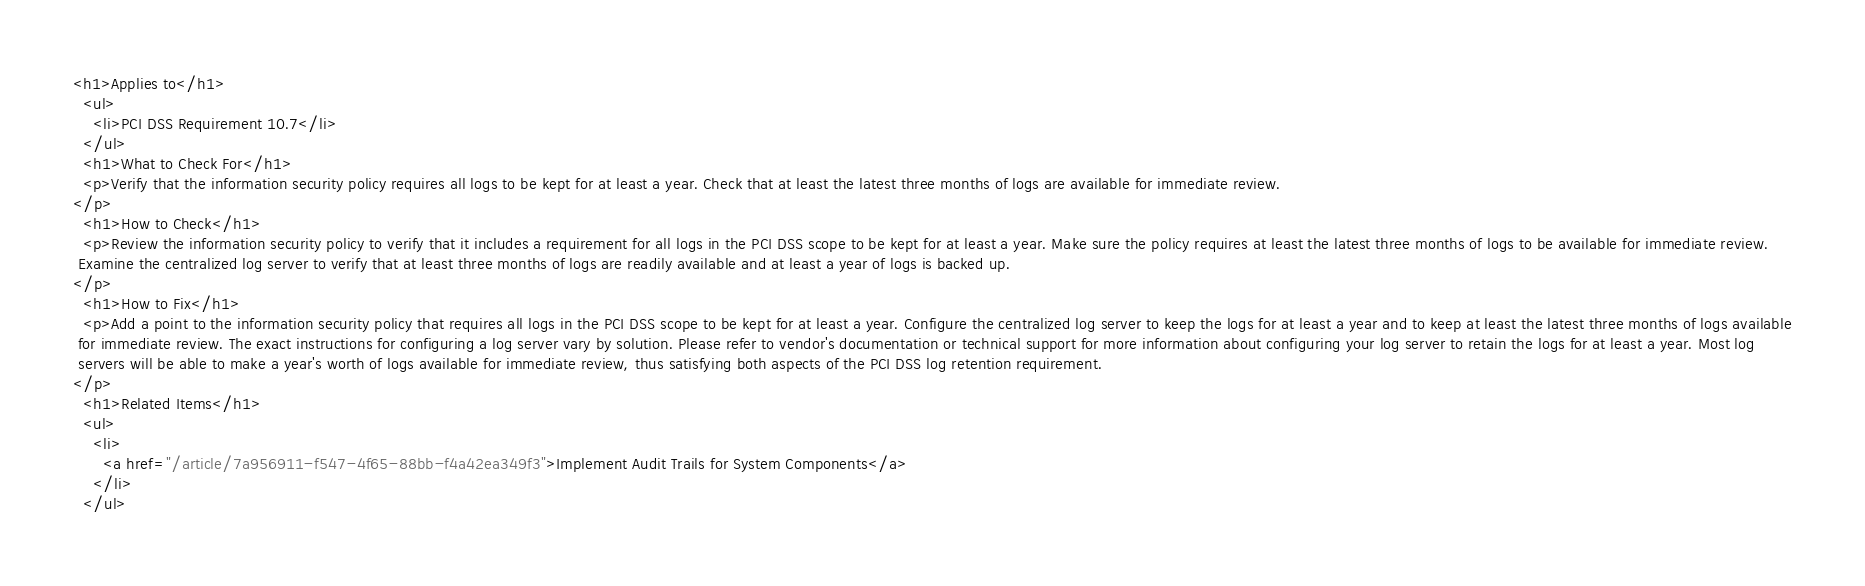<code> <loc_0><loc_0><loc_500><loc_500><_HTML_><h1>Applies to</h1>
  <ul>
    <li>PCI DSS Requirement 10.7</li>
  </ul>
  <h1>What to Check For</h1>
  <p>Verify that the information security policy requires all logs to be kept for at least a year. Check that at least the latest three months of logs are available for immediate review.
</p>
  <h1>How to Check</h1>
  <p>Review the information security policy to verify that it includes a requirement for all logs in the PCI DSS scope to be kept for at least a year. Make sure the policy requires at least the latest three months of logs to be available for immediate review.
 Examine the centralized log server to verify that at least three months of logs are readily available and at least a year of logs is backed up.
</p>
  <h1>How to Fix</h1>
  <p>Add a point to the information security policy that requires all logs in the PCI DSS scope to be kept for at least a year. Configure the centralized log server to keep the logs for at least a year and to keep at least the latest three months of logs available
 for immediate review. The exact instructions for configuring a log server vary by solution. Please refer to vendor's documentation or technical support for more information about configuring your log server to retain the logs for at least a year. Most log
 servers will be able to make a year's worth of logs available for immediate review, thus satisfying both aspects of the PCI DSS log retention requirement.
</p>
  <h1>Related Items</h1>
  <ul>
    <li>
      <a href="/article/7a956911-f547-4f65-88bb-f4a42ea349f3">Implement Audit Trails for System Components</a>
    </li>
  </ul></code> 